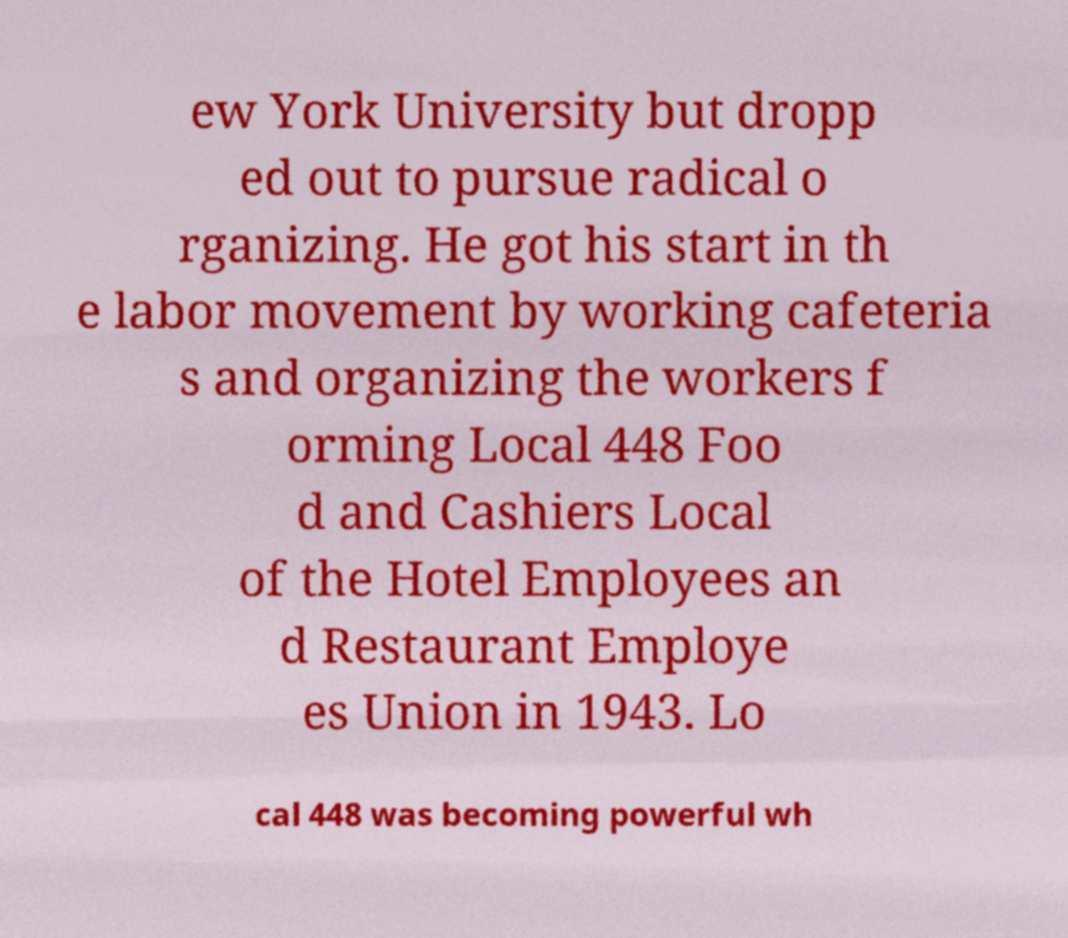Can you accurately transcribe the text from the provided image for me? ew York University but dropp ed out to pursue radical o rganizing. He got his start in th e labor movement by working cafeteria s and organizing the workers f orming Local 448 Foo d and Cashiers Local of the Hotel Employees an d Restaurant Employe es Union in 1943. Lo cal 448 was becoming powerful wh 